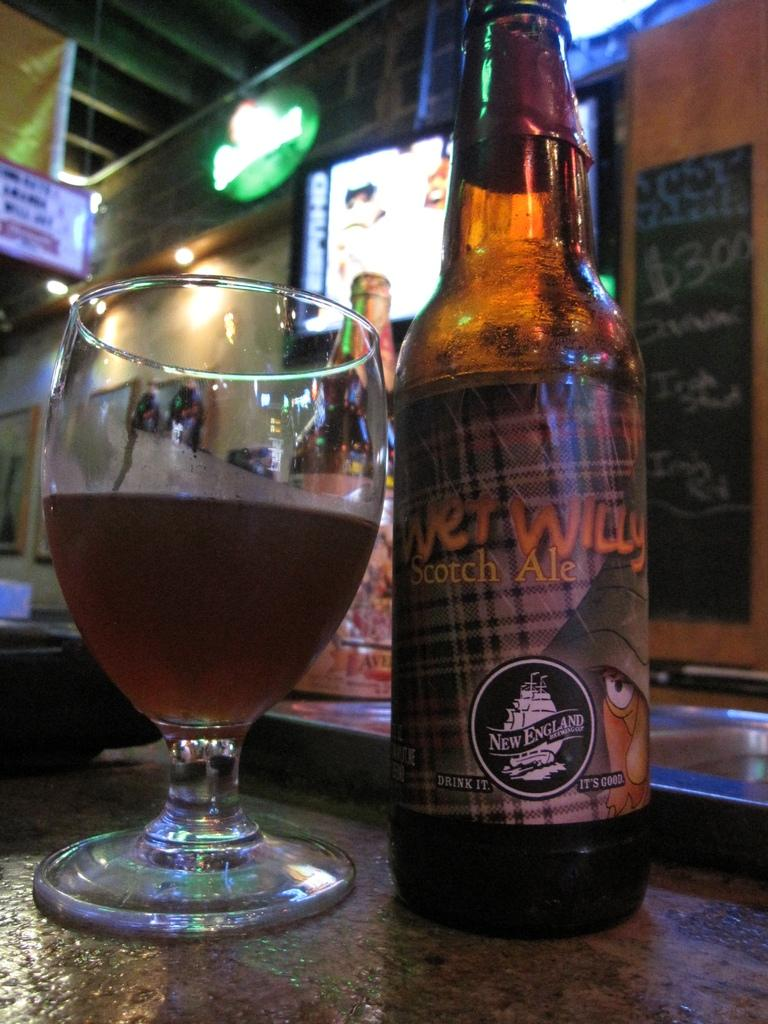<image>
Summarize the visual content of the image. a bottle of Wet Willy beer next to a glass 